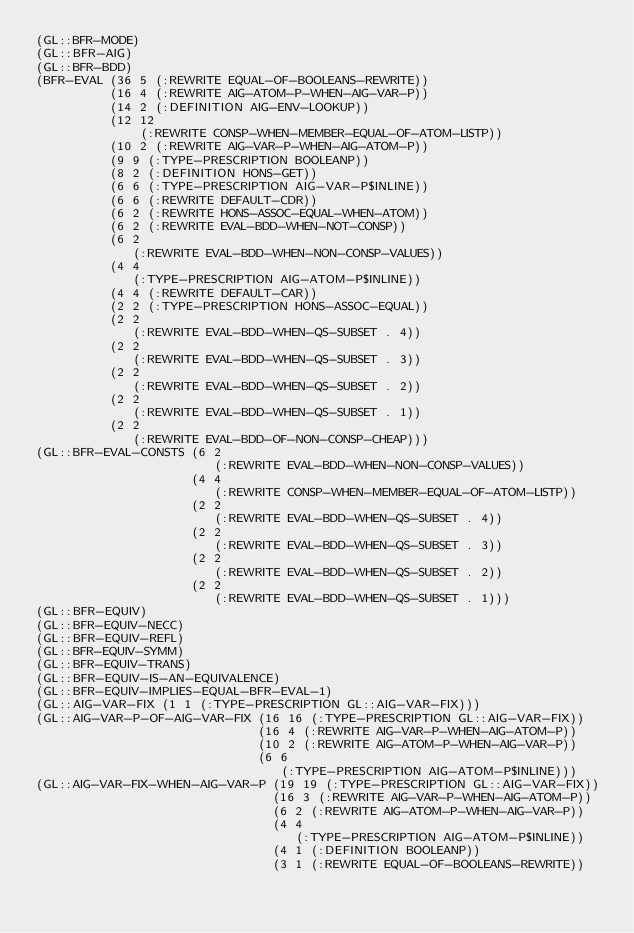Convert code to text. <code><loc_0><loc_0><loc_500><loc_500><_Lisp_>(GL::BFR-MODE)
(GL::BFR-AIG)
(GL::BFR-BDD)
(BFR-EVAL (36 5 (:REWRITE EQUAL-OF-BOOLEANS-REWRITE))
          (16 4 (:REWRITE AIG-ATOM-P-WHEN-AIG-VAR-P))
          (14 2 (:DEFINITION AIG-ENV-LOOKUP))
          (12 12
              (:REWRITE CONSP-WHEN-MEMBER-EQUAL-OF-ATOM-LISTP))
          (10 2 (:REWRITE AIG-VAR-P-WHEN-AIG-ATOM-P))
          (9 9 (:TYPE-PRESCRIPTION BOOLEANP))
          (8 2 (:DEFINITION HONS-GET))
          (6 6 (:TYPE-PRESCRIPTION AIG-VAR-P$INLINE))
          (6 6 (:REWRITE DEFAULT-CDR))
          (6 2 (:REWRITE HONS-ASSOC-EQUAL-WHEN-ATOM))
          (6 2 (:REWRITE EVAL-BDD-WHEN-NOT-CONSP))
          (6 2
             (:REWRITE EVAL-BDD-WHEN-NON-CONSP-VALUES))
          (4 4
             (:TYPE-PRESCRIPTION AIG-ATOM-P$INLINE))
          (4 4 (:REWRITE DEFAULT-CAR))
          (2 2 (:TYPE-PRESCRIPTION HONS-ASSOC-EQUAL))
          (2 2
             (:REWRITE EVAL-BDD-WHEN-QS-SUBSET . 4))
          (2 2
             (:REWRITE EVAL-BDD-WHEN-QS-SUBSET . 3))
          (2 2
             (:REWRITE EVAL-BDD-WHEN-QS-SUBSET . 2))
          (2 2
             (:REWRITE EVAL-BDD-WHEN-QS-SUBSET . 1))
          (2 2
             (:REWRITE EVAL-BDD-OF-NON-CONSP-CHEAP)))
(GL::BFR-EVAL-CONSTS (6 2
                        (:REWRITE EVAL-BDD-WHEN-NON-CONSP-VALUES))
                     (4 4
                        (:REWRITE CONSP-WHEN-MEMBER-EQUAL-OF-ATOM-LISTP))
                     (2 2
                        (:REWRITE EVAL-BDD-WHEN-QS-SUBSET . 4))
                     (2 2
                        (:REWRITE EVAL-BDD-WHEN-QS-SUBSET . 3))
                     (2 2
                        (:REWRITE EVAL-BDD-WHEN-QS-SUBSET . 2))
                     (2 2
                        (:REWRITE EVAL-BDD-WHEN-QS-SUBSET . 1)))
(GL::BFR-EQUIV)
(GL::BFR-EQUIV-NECC)
(GL::BFR-EQUIV-REFL)
(GL::BFR-EQUIV-SYMM)
(GL::BFR-EQUIV-TRANS)
(GL::BFR-EQUIV-IS-AN-EQUIVALENCE)
(GL::BFR-EQUIV-IMPLIES-EQUAL-BFR-EVAL-1)
(GL::AIG-VAR-FIX (1 1 (:TYPE-PRESCRIPTION GL::AIG-VAR-FIX)))
(GL::AIG-VAR-P-OF-AIG-VAR-FIX (16 16 (:TYPE-PRESCRIPTION GL::AIG-VAR-FIX))
                              (16 4 (:REWRITE AIG-VAR-P-WHEN-AIG-ATOM-P))
                              (10 2 (:REWRITE AIG-ATOM-P-WHEN-AIG-VAR-P))
                              (6 6
                                 (:TYPE-PRESCRIPTION AIG-ATOM-P$INLINE)))
(GL::AIG-VAR-FIX-WHEN-AIG-VAR-P (19 19 (:TYPE-PRESCRIPTION GL::AIG-VAR-FIX))
                                (16 3 (:REWRITE AIG-VAR-P-WHEN-AIG-ATOM-P))
                                (6 2 (:REWRITE AIG-ATOM-P-WHEN-AIG-VAR-P))
                                (4 4
                                   (:TYPE-PRESCRIPTION AIG-ATOM-P$INLINE))
                                (4 1 (:DEFINITION BOOLEANP))
                                (3 1 (:REWRITE EQUAL-OF-BOOLEANS-REWRITE))</code> 